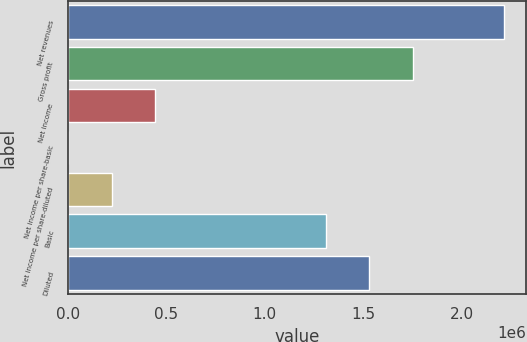<chart> <loc_0><loc_0><loc_500><loc_500><bar_chart><fcel>Net revenues<fcel>Gross profit<fcel>Net income<fcel>Net income per share-basic<fcel>Net income per share-diluted<fcel>Basic<fcel>Diluted<nl><fcel>2.21538e+06<fcel>1.75312e+06<fcel>443076<fcel>0.31<fcel>221538<fcel>1.31004e+06<fcel>1.53158e+06<nl></chart> 